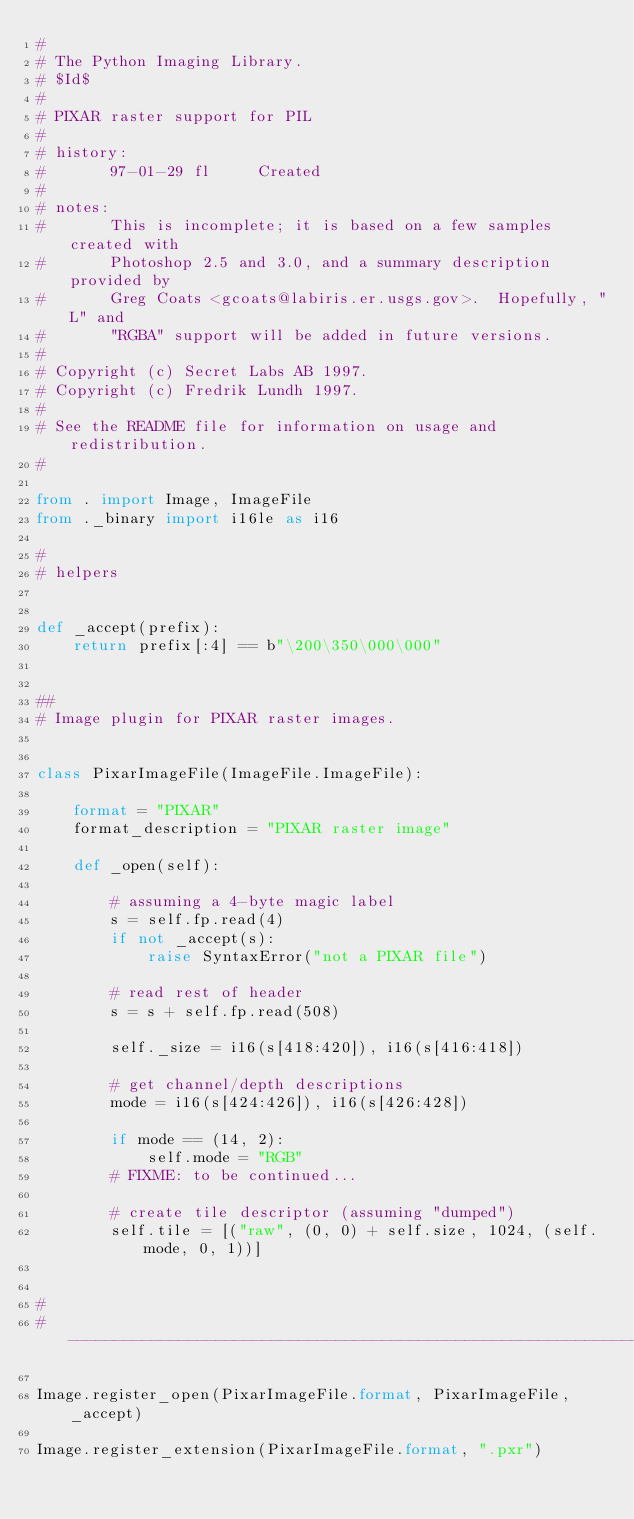<code> <loc_0><loc_0><loc_500><loc_500><_Python_>#
# The Python Imaging Library.
# $Id$
#
# PIXAR raster support for PIL
#
# history:
#       97-01-29 fl     Created
#
# notes:
#       This is incomplete; it is based on a few samples created with
#       Photoshop 2.5 and 3.0, and a summary description provided by
#       Greg Coats <gcoats@labiris.er.usgs.gov>.  Hopefully, "L" and
#       "RGBA" support will be added in future versions.
#
# Copyright (c) Secret Labs AB 1997.
# Copyright (c) Fredrik Lundh 1997.
#
# See the README file for information on usage and redistribution.
#

from . import Image, ImageFile
from ._binary import i16le as i16

#
# helpers


def _accept(prefix):
    return prefix[:4] == b"\200\350\000\000"


##
# Image plugin for PIXAR raster images.


class PixarImageFile(ImageFile.ImageFile):

    format = "PIXAR"
    format_description = "PIXAR raster image"

    def _open(self):

        # assuming a 4-byte magic label
        s = self.fp.read(4)
        if not _accept(s):
            raise SyntaxError("not a PIXAR file")

        # read rest of header
        s = s + self.fp.read(508)

        self._size = i16(s[418:420]), i16(s[416:418])

        # get channel/depth descriptions
        mode = i16(s[424:426]), i16(s[426:428])

        if mode == (14, 2):
            self.mode = "RGB"
        # FIXME: to be continued...

        # create tile descriptor (assuming "dumped")
        self.tile = [("raw", (0, 0) + self.size, 1024, (self.mode, 0, 1))]


#
# --------------------------------------------------------------------

Image.register_open(PixarImageFile.format, PixarImageFile, _accept)

Image.register_extension(PixarImageFile.format, ".pxr")
</code> 